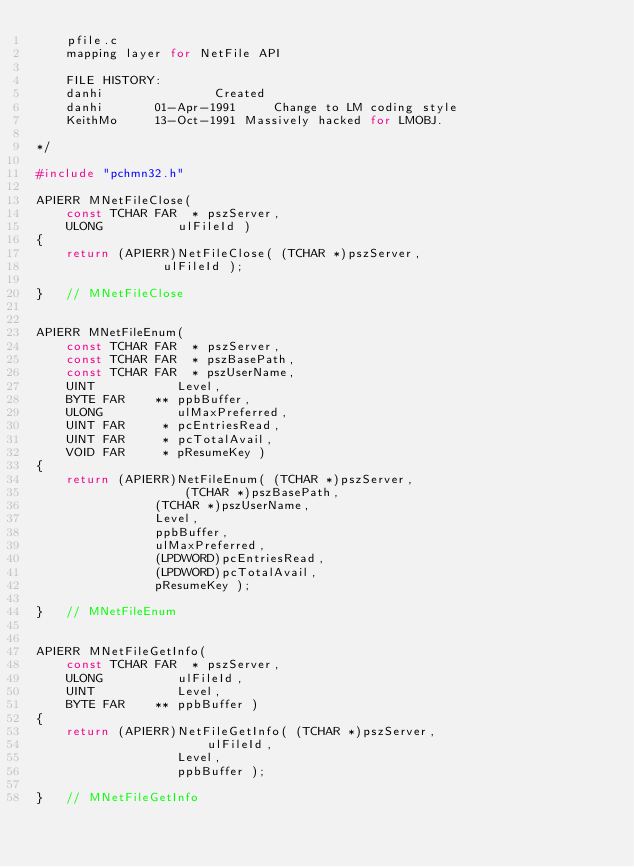<code> <loc_0><loc_0><loc_500><loc_500><_C_>    pfile.c
    mapping layer for NetFile API

    FILE HISTORY:
	danhi				Created
	danhi		01-Apr-1991 	Change to LM coding style
	KeithMo		13-Oct-1991	Massively hacked for LMOBJ.

*/

#include "pchmn32.h"

APIERR MNetFileClose(
	const TCHAR FAR	 * pszServer,
	ULONG		   ulFileId )
{
    return (APIERR)NetFileClose( (TCHAR *)pszServer,
				 ulFileId );

}   // MNetFileClose


APIERR MNetFileEnum(
	const TCHAR FAR	 * pszServer,
	const TCHAR FAR	 * pszBasePath,
	const TCHAR FAR	 * pszUserName,
	UINT		   Level,
	BYTE FAR	** ppbBuffer,
	ULONG		   ulMaxPreferred,
	UINT FAR	 * pcEntriesRead,
	UINT FAR	 * pcTotalAvail,
	VOID FAR	 * pResumeKey )
{
    return (APIERR)NetFileEnum( (TCHAR *)pszServer,
    				(TCHAR *)pszBasePath,
				(TCHAR *)pszUserName,
				Level,
				ppbBuffer,
				ulMaxPreferred,
				(LPDWORD)pcEntriesRead,
				(LPDWORD)pcTotalAvail,
				pResumeKey );

}   // MNetFileEnum


APIERR MNetFileGetInfo(
	const TCHAR FAR	 * pszServer,
	ULONG		   ulFileId,
	UINT		   Level,
	BYTE FAR	** ppbBuffer )
{
    return (APIERR)NetFileGetInfo( (TCHAR *)pszServer,
    				   ulFileId,
				   Level,
				   ppbBuffer );

}   // MNetFileGetInfo
</code> 